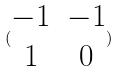<formula> <loc_0><loc_0><loc_500><loc_500>( \begin{matrix} - 1 & - 1 \\ 1 & 0 \end{matrix} )</formula> 